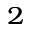Convert formula to latex. <formula><loc_0><loc_0><loc_500><loc_500>_ { 2 }</formula> 